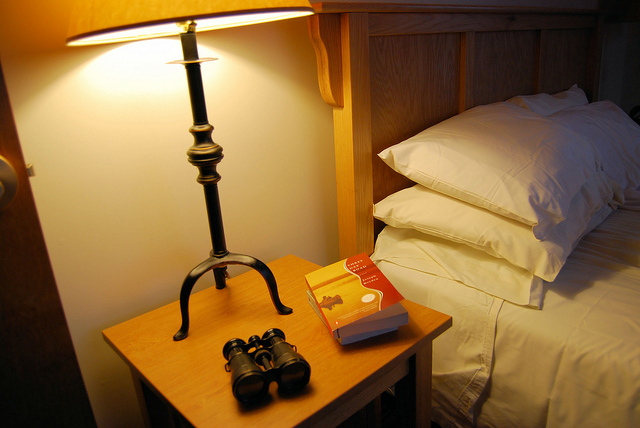What time of day does it seem to be considering the lighting in the room? The lighting in the room is soft and warm, with the lamp on the bedside table being the primary light source, hinting that it might be evening or night time. 